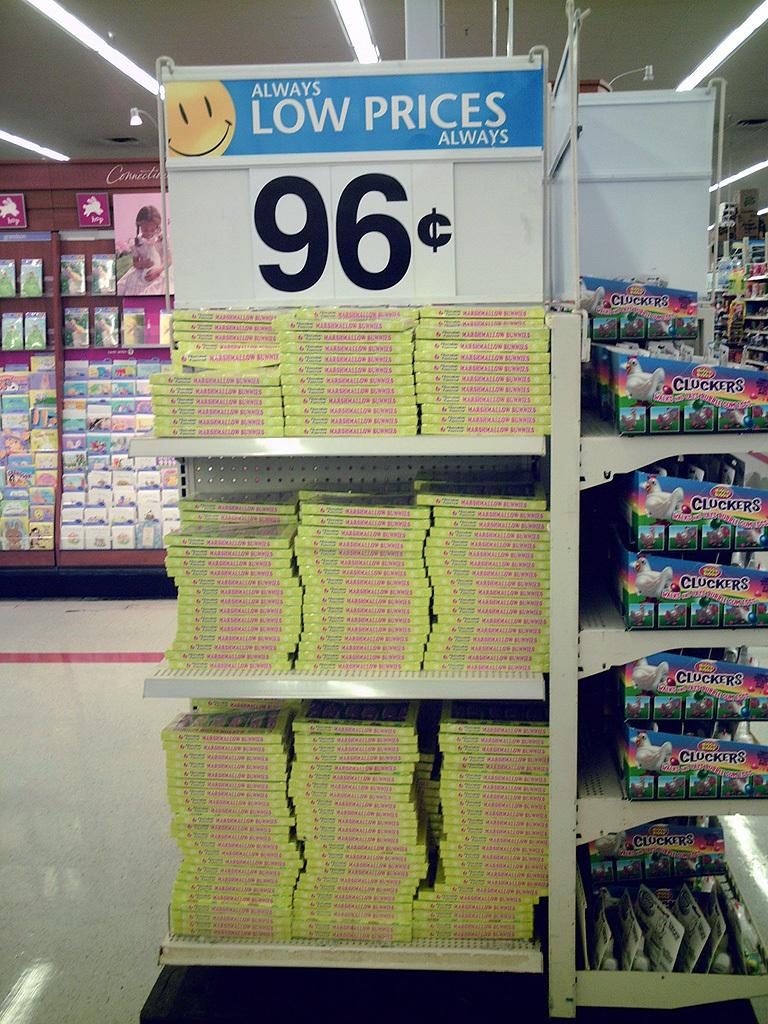<image>
Render a clear and concise summary of the photo. a shel in Walmart displaying for 96 cents 